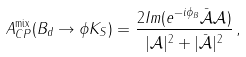Convert formula to latex. <formula><loc_0><loc_0><loc_500><loc_500>A _ { C P } ^ { \text {mix} } ( B _ { d } \to \phi K _ { S } ) = \frac { 2 I m ( e ^ { - i \phi _ { B } } \bar { \mathcal { A } } \mathcal { A } ) } { | \mathcal { A } | ^ { 2 } + | \bar { \mathcal { A } } | ^ { 2 } } \, ,</formula> 